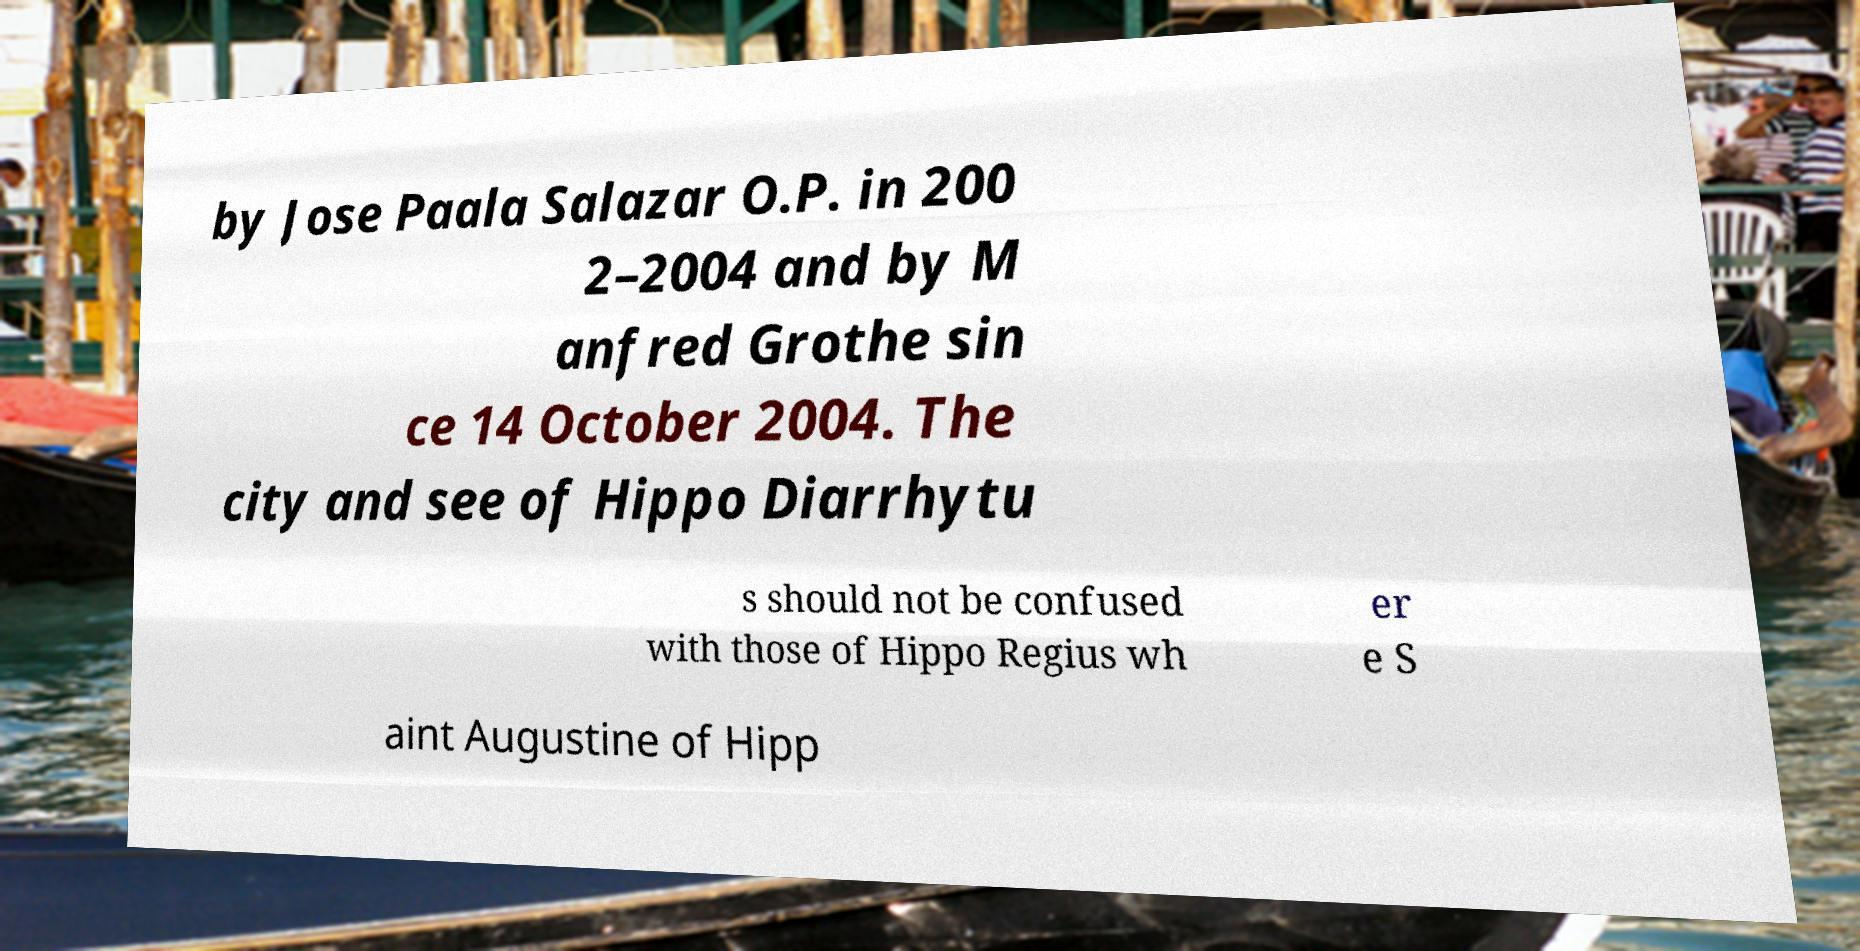Can you read and provide the text displayed in the image?This photo seems to have some interesting text. Can you extract and type it out for me? by Jose Paala Salazar O.P. in 200 2–2004 and by M anfred Grothe sin ce 14 October 2004. The city and see of Hippo Diarrhytu s should not be confused with those of Hippo Regius wh er e S aint Augustine of Hipp 